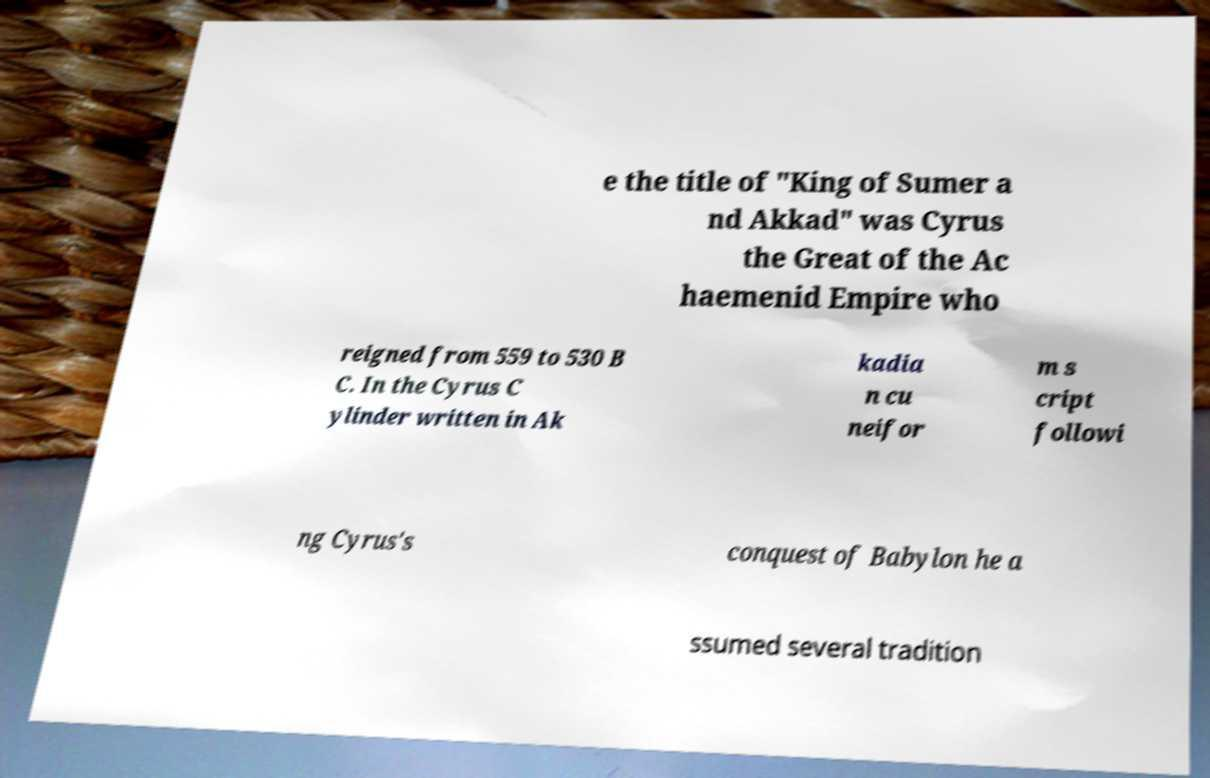Could you assist in decoding the text presented in this image and type it out clearly? e the title of "King of Sumer a nd Akkad" was Cyrus the Great of the Ac haemenid Empire who reigned from 559 to 530 B C. In the Cyrus C ylinder written in Ak kadia n cu neifor m s cript followi ng Cyrus's conquest of Babylon he a ssumed several tradition 